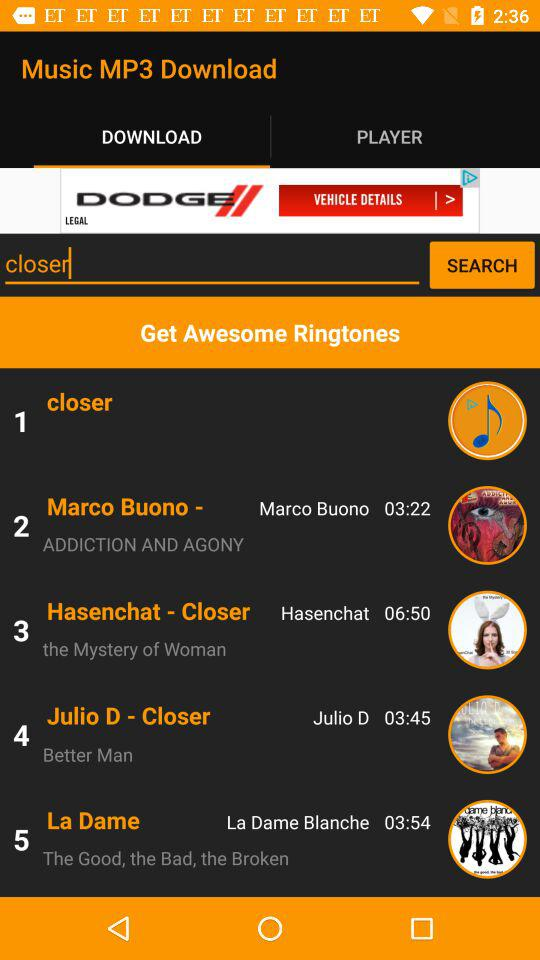What is the duration of the song "Hasenchat - Closer"? The duration is 06:50. 